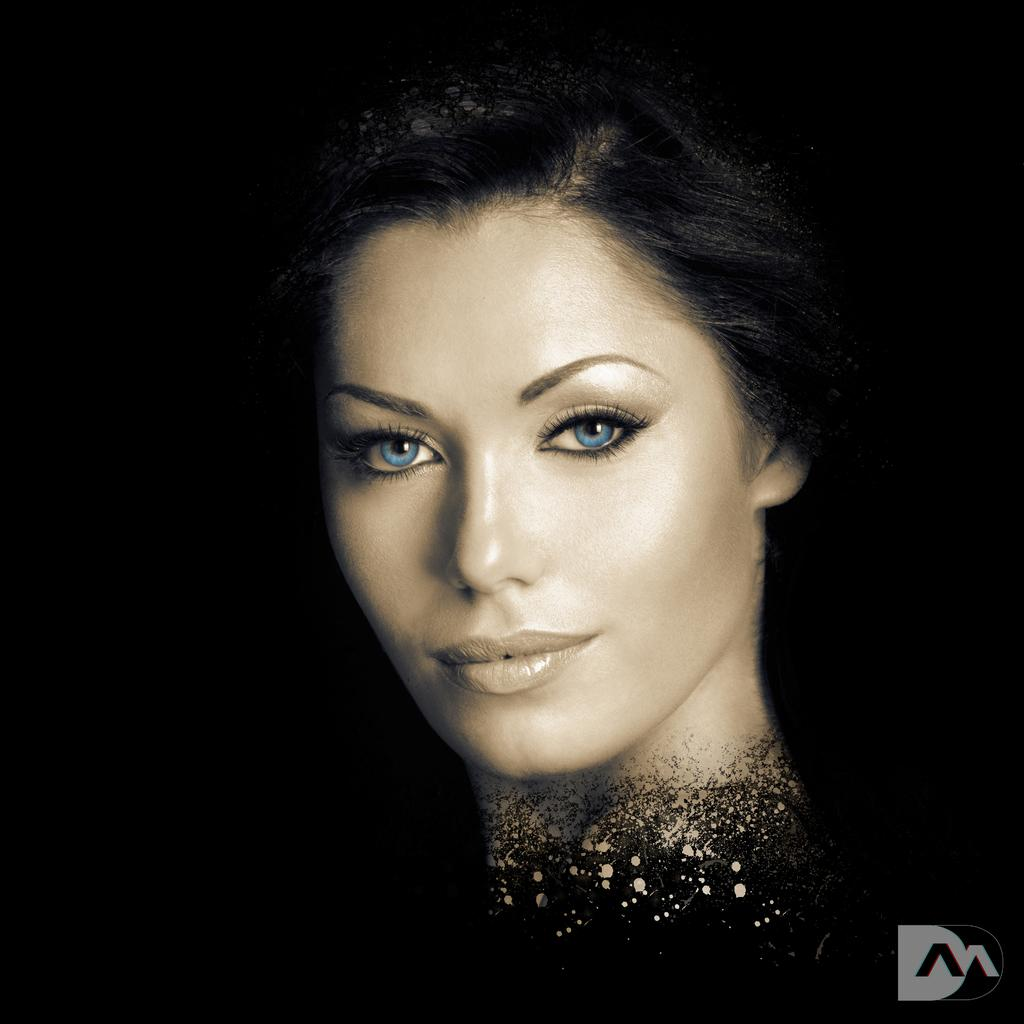Who is the main subject in the image? There is a woman in the image. What can be observed about the background of the image? The background of the image is dark. Is there any additional information or symbol present in the image? Yes, there is a logo in the bottom right corner of the image. How many bricks are stacked in the background of the image? There are no bricks visible in the image; the background is dark. What type of show is the woman performing in the image? There is no indication of a show or performance in the image; it simply features a woman. 